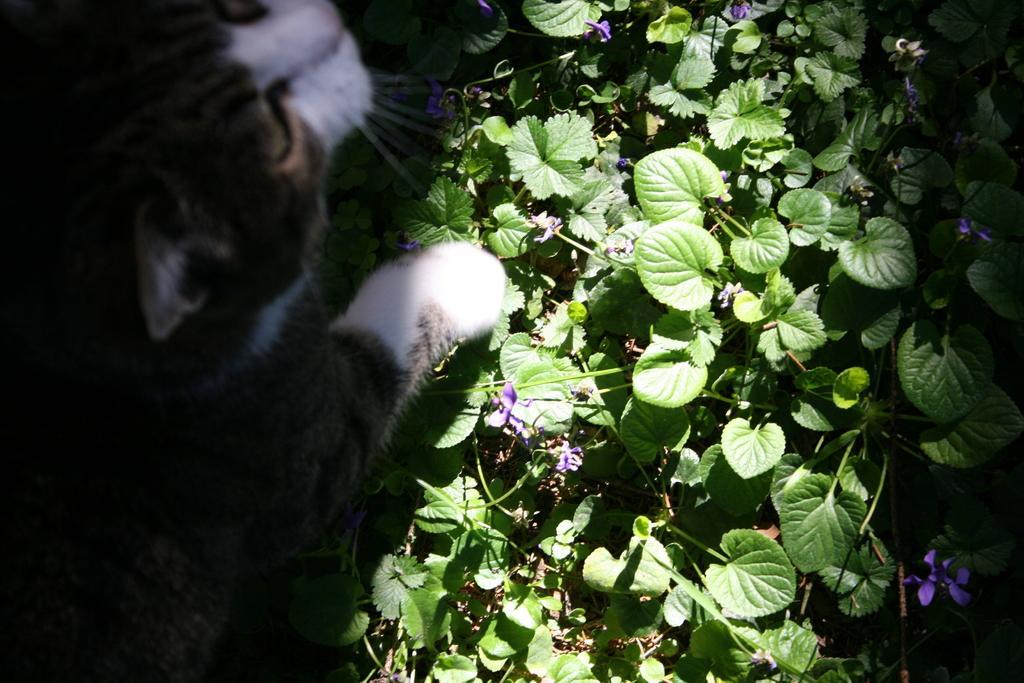How would you summarize this image in a sentence or two? In the picture we can see a cat and beside it we can see many plants with some flowers to it. 